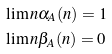Convert formula to latex. <formula><loc_0><loc_0><loc_500><loc_500>& \lim n \alpha _ { A } ( n ) = 1 \\ & \lim n \beta _ { A } ( n ) = 0</formula> 